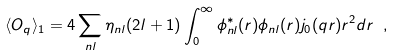<formula> <loc_0><loc_0><loc_500><loc_500>\langle { O } _ { q } \rangle _ { 1 } = 4 \sum _ { n l } \eta _ { n l } ( 2 l + 1 ) \int _ { 0 } ^ { \infty } \phi ^ { * } _ { n l } ( r ) \phi _ { n l } ( r ) j _ { 0 } ( q r ) r ^ { 2 } d r \ ,</formula> 